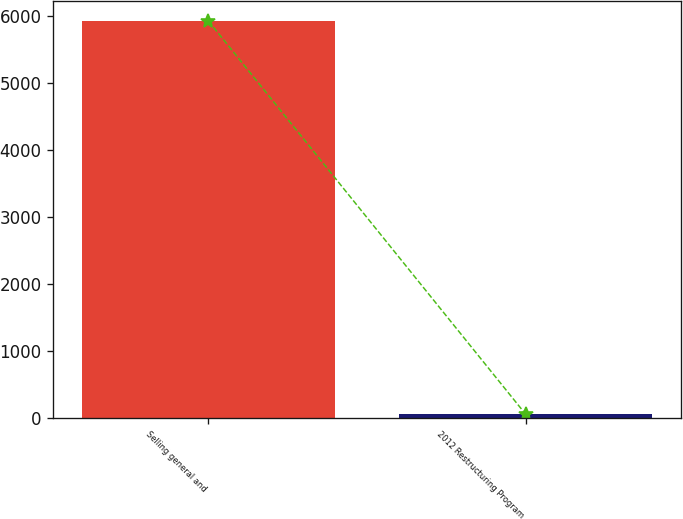Convert chart to OTSL. <chart><loc_0><loc_0><loc_500><loc_500><bar_chart><fcel>Selling general and<fcel>2012 Restructuring Program<nl><fcel>5920<fcel>62<nl></chart> 